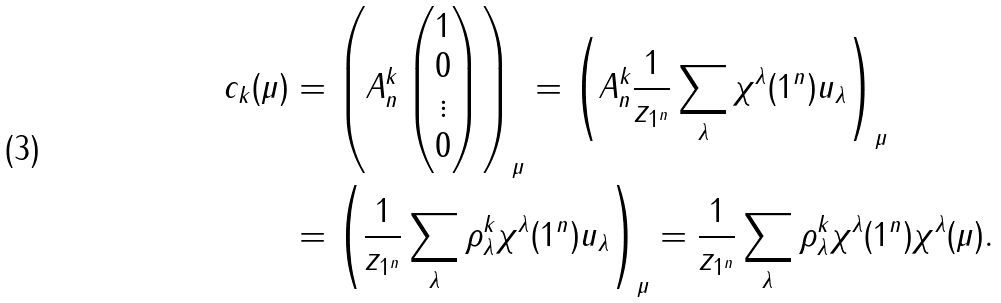Convert formula to latex. <formula><loc_0><loc_0><loc_500><loc_500>c _ { k } ( \mu ) & = \left ( A _ { n } ^ { k } \begin{pmatrix} 1 \\ 0 \\ \vdots \\ 0 \end{pmatrix} \right ) _ { \mu } = \left ( A _ { n } ^ { k } \frac { 1 } { z _ { 1 ^ { n } } } \sum _ { \lambda } \chi ^ { \lambda } ( 1 ^ { n } ) u _ { \lambda } \right ) _ { \mu } \\ & = \left ( \frac { 1 } { z _ { 1 ^ { n } } } \sum _ { \lambda } \rho _ { \lambda } ^ { k } \chi ^ { \lambda } ( 1 ^ { n } ) u _ { \lambda } \right ) _ { \mu } = \frac { 1 } { z _ { 1 ^ { n } } } \sum _ { \lambda } \rho _ { \lambda } ^ { k } \chi ^ { \lambda } ( 1 ^ { n } ) \chi ^ { \lambda } ( \mu ) .</formula> 